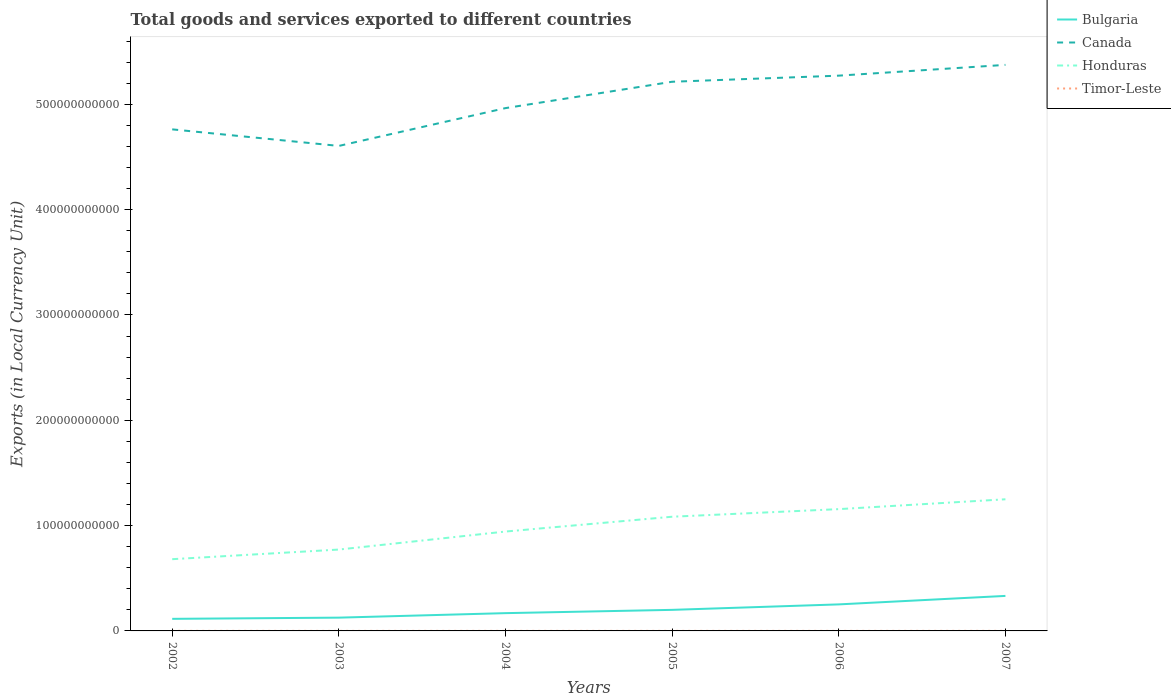Across all years, what is the maximum Amount of goods and services exports in Bulgaria?
Your response must be concise. 1.15e+1. In which year was the Amount of goods and services exports in Timor-Leste maximum?
Provide a succinct answer. 2003. What is the total Amount of goods and services exports in Timor-Leste in the graph?
Provide a short and direct response. -2.40e+07. What is the difference between the highest and the second highest Amount of goods and services exports in Canada?
Offer a very short reply. 7.69e+1. What is the difference between the highest and the lowest Amount of goods and services exports in Canada?
Make the answer very short. 3. Is the Amount of goods and services exports in Honduras strictly greater than the Amount of goods and services exports in Bulgaria over the years?
Offer a very short reply. No. How many lines are there?
Your answer should be compact. 4. How many years are there in the graph?
Your response must be concise. 6. What is the difference between two consecutive major ticks on the Y-axis?
Your answer should be very brief. 1.00e+11. Are the values on the major ticks of Y-axis written in scientific E-notation?
Your answer should be compact. No. How are the legend labels stacked?
Your answer should be very brief. Vertical. What is the title of the graph?
Offer a very short reply. Total goods and services exported to different countries. What is the label or title of the Y-axis?
Your answer should be compact. Exports (in Local Currency Unit). What is the Exports (in Local Currency Unit) in Bulgaria in 2002?
Your answer should be very brief. 1.15e+1. What is the Exports (in Local Currency Unit) in Canada in 2002?
Your answer should be compact. 4.76e+11. What is the Exports (in Local Currency Unit) in Honduras in 2002?
Keep it short and to the point. 6.81e+1. What is the Exports (in Local Currency Unit) of Timor-Leste in 2002?
Offer a terse response. 3.90e+07. What is the Exports (in Local Currency Unit) of Bulgaria in 2003?
Provide a short and direct response. 1.26e+1. What is the Exports (in Local Currency Unit) in Canada in 2003?
Your answer should be compact. 4.60e+11. What is the Exports (in Local Currency Unit) of Honduras in 2003?
Give a very brief answer. 7.73e+1. What is the Exports (in Local Currency Unit) of Timor-Leste in 2003?
Make the answer very short. 3.60e+07. What is the Exports (in Local Currency Unit) in Bulgaria in 2004?
Your response must be concise. 1.69e+1. What is the Exports (in Local Currency Unit) in Canada in 2004?
Offer a very short reply. 4.96e+11. What is the Exports (in Local Currency Unit) of Honduras in 2004?
Ensure brevity in your answer.  9.44e+1. What is the Exports (in Local Currency Unit) of Timor-Leste in 2004?
Provide a succinct answer. 3.90e+07. What is the Exports (in Local Currency Unit) of Bulgaria in 2005?
Your answer should be compact. 2.00e+1. What is the Exports (in Local Currency Unit) in Canada in 2005?
Your answer should be very brief. 5.21e+11. What is the Exports (in Local Currency Unit) in Honduras in 2005?
Offer a terse response. 1.08e+11. What is the Exports (in Local Currency Unit) of Timor-Leste in 2005?
Keep it short and to the point. 4.00e+07. What is the Exports (in Local Currency Unit) of Bulgaria in 2006?
Ensure brevity in your answer.  2.52e+1. What is the Exports (in Local Currency Unit) of Canada in 2006?
Give a very brief answer. 5.27e+11. What is the Exports (in Local Currency Unit) of Honduras in 2006?
Provide a succinct answer. 1.16e+11. What is the Exports (in Local Currency Unit) in Timor-Leste in 2006?
Your answer should be very brief. 4.50e+07. What is the Exports (in Local Currency Unit) in Bulgaria in 2007?
Offer a terse response. 3.32e+1. What is the Exports (in Local Currency Unit) in Canada in 2007?
Provide a succinct answer. 5.37e+11. What is the Exports (in Local Currency Unit) of Honduras in 2007?
Offer a very short reply. 1.25e+11. What is the Exports (in Local Currency Unit) of Timor-Leste in 2007?
Offer a terse response. 6.00e+07. Across all years, what is the maximum Exports (in Local Currency Unit) of Bulgaria?
Provide a short and direct response. 3.32e+1. Across all years, what is the maximum Exports (in Local Currency Unit) in Canada?
Provide a succinct answer. 5.37e+11. Across all years, what is the maximum Exports (in Local Currency Unit) of Honduras?
Give a very brief answer. 1.25e+11. Across all years, what is the maximum Exports (in Local Currency Unit) in Timor-Leste?
Keep it short and to the point. 6.00e+07. Across all years, what is the minimum Exports (in Local Currency Unit) of Bulgaria?
Your answer should be compact. 1.15e+1. Across all years, what is the minimum Exports (in Local Currency Unit) of Canada?
Offer a terse response. 4.60e+11. Across all years, what is the minimum Exports (in Local Currency Unit) in Honduras?
Your answer should be compact. 6.81e+1. Across all years, what is the minimum Exports (in Local Currency Unit) of Timor-Leste?
Ensure brevity in your answer.  3.60e+07. What is the total Exports (in Local Currency Unit) of Bulgaria in the graph?
Provide a short and direct response. 1.19e+11. What is the total Exports (in Local Currency Unit) of Canada in the graph?
Offer a terse response. 3.02e+12. What is the total Exports (in Local Currency Unit) in Honduras in the graph?
Make the answer very short. 5.89e+11. What is the total Exports (in Local Currency Unit) in Timor-Leste in the graph?
Provide a short and direct response. 2.59e+08. What is the difference between the Exports (in Local Currency Unit) in Bulgaria in 2002 and that in 2003?
Provide a short and direct response. -1.15e+09. What is the difference between the Exports (in Local Currency Unit) of Canada in 2002 and that in 2003?
Your answer should be compact. 1.57e+1. What is the difference between the Exports (in Local Currency Unit) of Honduras in 2002 and that in 2003?
Give a very brief answer. -9.15e+09. What is the difference between the Exports (in Local Currency Unit) of Timor-Leste in 2002 and that in 2003?
Offer a terse response. 3.00e+06. What is the difference between the Exports (in Local Currency Unit) in Bulgaria in 2002 and that in 2004?
Provide a succinct answer. -5.41e+09. What is the difference between the Exports (in Local Currency Unit) of Canada in 2002 and that in 2004?
Your answer should be very brief. -2.02e+1. What is the difference between the Exports (in Local Currency Unit) in Honduras in 2002 and that in 2004?
Offer a terse response. -2.62e+1. What is the difference between the Exports (in Local Currency Unit) in Bulgaria in 2002 and that in 2005?
Your answer should be compact. -8.53e+09. What is the difference between the Exports (in Local Currency Unit) of Canada in 2002 and that in 2005?
Provide a short and direct response. -4.52e+1. What is the difference between the Exports (in Local Currency Unit) in Honduras in 2002 and that in 2005?
Ensure brevity in your answer.  -4.03e+1. What is the difference between the Exports (in Local Currency Unit) of Bulgaria in 2002 and that in 2006?
Make the answer very short. -1.37e+1. What is the difference between the Exports (in Local Currency Unit) in Canada in 2002 and that in 2006?
Keep it short and to the point. -5.10e+1. What is the difference between the Exports (in Local Currency Unit) of Honduras in 2002 and that in 2006?
Give a very brief answer. -4.75e+1. What is the difference between the Exports (in Local Currency Unit) of Timor-Leste in 2002 and that in 2006?
Your response must be concise. -6.00e+06. What is the difference between the Exports (in Local Currency Unit) of Bulgaria in 2002 and that in 2007?
Offer a terse response. -2.18e+1. What is the difference between the Exports (in Local Currency Unit) of Canada in 2002 and that in 2007?
Ensure brevity in your answer.  -6.12e+1. What is the difference between the Exports (in Local Currency Unit) of Honduras in 2002 and that in 2007?
Offer a very short reply. -5.69e+1. What is the difference between the Exports (in Local Currency Unit) of Timor-Leste in 2002 and that in 2007?
Your answer should be very brief. -2.10e+07. What is the difference between the Exports (in Local Currency Unit) of Bulgaria in 2003 and that in 2004?
Your response must be concise. -4.27e+09. What is the difference between the Exports (in Local Currency Unit) in Canada in 2003 and that in 2004?
Give a very brief answer. -3.59e+1. What is the difference between the Exports (in Local Currency Unit) in Honduras in 2003 and that in 2004?
Offer a terse response. -1.71e+1. What is the difference between the Exports (in Local Currency Unit) in Bulgaria in 2003 and that in 2005?
Provide a short and direct response. -7.39e+09. What is the difference between the Exports (in Local Currency Unit) in Canada in 2003 and that in 2005?
Provide a succinct answer. -6.09e+1. What is the difference between the Exports (in Local Currency Unit) in Honduras in 2003 and that in 2005?
Ensure brevity in your answer.  -3.12e+1. What is the difference between the Exports (in Local Currency Unit) in Bulgaria in 2003 and that in 2006?
Make the answer very short. -1.26e+1. What is the difference between the Exports (in Local Currency Unit) in Canada in 2003 and that in 2006?
Give a very brief answer. -6.67e+1. What is the difference between the Exports (in Local Currency Unit) in Honduras in 2003 and that in 2006?
Give a very brief answer. -3.84e+1. What is the difference between the Exports (in Local Currency Unit) in Timor-Leste in 2003 and that in 2006?
Your answer should be very brief. -9.00e+06. What is the difference between the Exports (in Local Currency Unit) of Bulgaria in 2003 and that in 2007?
Provide a succinct answer. -2.06e+1. What is the difference between the Exports (in Local Currency Unit) of Canada in 2003 and that in 2007?
Keep it short and to the point. -7.69e+1. What is the difference between the Exports (in Local Currency Unit) of Honduras in 2003 and that in 2007?
Ensure brevity in your answer.  -4.77e+1. What is the difference between the Exports (in Local Currency Unit) of Timor-Leste in 2003 and that in 2007?
Keep it short and to the point. -2.40e+07. What is the difference between the Exports (in Local Currency Unit) in Bulgaria in 2004 and that in 2005?
Keep it short and to the point. -3.12e+09. What is the difference between the Exports (in Local Currency Unit) of Canada in 2004 and that in 2005?
Provide a short and direct response. -2.50e+1. What is the difference between the Exports (in Local Currency Unit) of Honduras in 2004 and that in 2005?
Your response must be concise. -1.41e+1. What is the difference between the Exports (in Local Currency Unit) in Bulgaria in 2004 and that in 2006?
Keep it short and to the point. -8.31e+09. What is the difference between the Exports (in Local Currency Unit) in Canada in 2004 and that in 2006?
Offer a very short reply. -3.08e+1. What is the difference between the Exports (in Local Currency Unit) in Honduras in 2004 and that in 2006?
Your answer should be very brief. -2.13e+1. What is the difference between the Exports (in Local Currency Unit) in Timor-Leste in 2004 and that in 2006?
Ensure brevity in your answer.  -6.00e+06. What is the difference between the Exports (in Local Currency Unit) of Bulgaria in 2004 and that in 2007?
Ensure brevity in your answer.  -1.64e+1. What is the difference between the Exports (in Local Currency Unit) of Canada in 2004 and that in 2007?
Your response must be concise. -4.10e+1. What is the difference between the Exports (in Local Currency Unit) of Honduras in 2004 and that in 2007?
Your response must be concise. -3.06e+1. What is the difference between the Exports (in Local Currency Unit) in Timor-Leste in 2004 and that in 2007?
Ensure brevity in your answer.  -2.10e+07. What is the difference between the Exports (in Local Currency Unit) in Bulgaria in 2005 and that in 2006?
Your answer should be compact. -5.19e+09. What is the difference between the Exports (in Local Currency Unit) in Canada in 2005 and that in 2006?
Give a very brief answer. -5.79e+09. What is the difference between the Exports (in Local Currency Unit) in Honduras in 2005 and that in 2006?
Offer a terse response. -7.21e+09. What is the difference between the Exports (in Local Currency Unit) in Timor-Leste in 2005 and that in 2006?
Your answer should be compact. -5.00e+06. What is the difference between the Exports (in Local Currency Unit) of Bulgaria in 2005 and that in 2007?
Your answer should be compact. -1.32e+1. What is the difference between the Exports (in Local Currency Unit) in Canada in 2005 and that in 2007?
Provide a succinct answer. -1.60e+1. What is the difference between the Exports (in Local Currency Unit) of Honduras in 2005 and that in 2007?
Your answer should be very brief. -1.66e+1. What is the difference between the Exports (in Local Currency Unit) of Timor-Leste in 2005 and that in 2007?
Provide a short and direct response. -2.00e+07. What is the difference between the Exports (in Local Currency Unit) in Bulgaria in 2006 and that in 2007?
Make the answer very short. -8.06e+09. What is the difference between the Exports (in Local Currency Unit) of Canada in 2006 and that in 2007?
Offer a very short reply. -1.02e+1. What is the difference between the Exports (in Local Currency Unit) of Honduras in 2006 and that in 2007?
Make the answer very short. -9.35e+09. What is the difference between the Exports (in Local Currency Unit) in Timor-Leste in 2006 and that in 2007?
Provide a succinct answer. -1.50e+07. What is the difference between the Exports (in Local Currency Unit) in Bulgaria in 2002 and the Exports (in Local Currency Unit) in Canada in 2003?
Offer a very short reply. -4.49e+11. What is the difference between the Exports (in Local Currency Unit) in Bulgaria in 2002 and the Exports (in Local Currency Unit) in Honduras in 2003?
Your answer should be compact. -6.58e+1. What is the difference between the Exports (in Local Currency Unit) of Bulgaria in 2002 and the Exports (in Local Currency Unit) of Timor-Leste in 2003?
Your answer should be compact. 1.14e+1. What is the difference between the Exports (in Local Currency Unit) in Canada in 2002 and the Exports (in Local Currency Unit) in Honduras in 2003?
Provide a succinct answer. 3.99e+11. What is the difference between the Exports (in Local Currency Unit) of Canada in 2002 and the Exports (in Local Currency Unit) of Timor-Leste in 2003?
Your answer should be very brief. 4.76e+11. What is the difference between the Exports (in Local Currency Unit) of Honduras in 2002 and the Exports (in Local Currency Unit) of Timor-Leste in 2003?
Make the answer very short. 6.81e+1. What is the difference between the Exports (in Local Currency Unit) of Bulgaria in 2002 and the Exports (in Local Currency Unit) of Canada in 2004?
Offer a very short reply. -4.85e+11. What is the difference between the Exports (in Local Currency Unit) in Bulgaria in 2002 and the Exports (in Local Currency Unit) in Honduras in 2004?
Your answer should be compact. -8.29e+1. What is the difference between the Exports (in Local Currency Unit) in Bulgaria in 2002 and the Exports (in Local Currency Unit) in Timor-Leste in 2004?
Your answer should be very brief. 1.14e+1. What is the difference between the Exports (in Local Currency Unit) in Canada in 2002 and the Exports (in Local Currency Unit) in Honduras in 2004?
Give a very brief answer. 3.82e+11. What is the difference between the Exports (in Local Currency Unit) in Canada in 2002 and the Exports (in Local Currency Unit) in Timor-Leste in 2004?
Your response must be concise. 4.76e+11. What is the difference between the Exports (in Local Currency Unit) of Honduras in 2002 and the Exports (in Local Currency Unit) of Timor-Leste in 2004?
Keep it short and to the point. 6.81e+1. What is the difference between the Exports (in Local Currency Unit) in Bulgaria in 2002 and the Exports (in Local Currency Unit) in Canada in 2005?
Offer a terse response. -5.10e+11. What is the difference between the Exports (in Local Currency Unit) of Bulgaria in 2002 and the Exports (in Local Currency Unit) of Honduras in 2005?
Offer a very short reply. -9.70e+1. What is the difference between the Exports (in Local Currency Unit) in Bulgaria in 2002 and the Exports (in Local Currency Unit) in Timor-Leste in 2005?
Offer a very short reply. 1.14e+1. What is the difference between the Exports (in Local Currency Unit) of Canada in 2002 and the Exports (in Local Currency Unit) of Honduras in 2005?
Your answer should be very brief. 3.68e+11. What is the difference between the Exports (in Local Currency Unit) of Canada in 2002 and the Exports (in Local Currency Unit) of Timor-Leste in 2005?
Provide a succinct answer. 4.76e+11. What is the difference between the Exports (in Local Currency Unit) in Honduras in 2002 and the Exports (in Local Currency Unit) in Timor-Leste in 2005?
Offer a terse response. 6.81e+1. What is the difference between the Exports (in Local Currency Unit) of Bulgaria in 2002 and the Exports (in Local Currency Unit) of Canada in 2006?
Offer a very short reply. -5.16e+11. What is the difference between the Exports (in Local Currency Unit) in Bulgaria in 2002 and the Exports (in Local Currency Unit) in Honduras in 2006?
Ensure brevity in your answer.  -1.04e+11. What is the difference between the Exports (in Local Currency Unit) of Bulgaria in 2002 and the Exports (in Local Currency Unit) of Timor-Leste in 2006?
Provide a succinct answer. 1.14e+1. What is the difference between the Exports (in Local Currency Unit) in Canada in 2002 and the Exports (in Local Currency Unit) in Honduras in 2006?
Offer a terse response. 3.61e+11. What is the difference between the Exports (in Local Currency Unit) of Canada in 2002 and the Exports (in Local Currency Unit) of Timor-Leste in 2006?
Provide a short and direct response. 4.76e+11. What is the difference between the Exports (in Local Currency Unit) of Honduras in 2002 and the Exports (in Local Currency Unit) of Timor-Leste in 2006?
Give a very brief answer. 6.81e+1. What is the difference between the Exports (in Local Currency Unit) of Bulgaria in 2002 and the Exports (in Local Currency Unit) of Canada in 2007?
Ensure brevity in your answer.  -5.26e+11. What is the difference between the Exports (in Local Currency Unit) of Bulgaria in 2002 and the Exports (in Local Currency Unit) of Honduras in 2007?
Your response must be concise. -1.14e+11. What is the difference between the Exports (in Local Currency Unit) of Bulgaria in 2002 and the Exports (in Local Currency Unit) of Timor-Leste in 2007?
Your answer should be compact. 1.14e+1. What is the difference between the Exports (in Local Currency Unit) in Canada in 2002 and the Exports (in Local Currency Unit) in Honduras in 2007?
Your response must be concise. 3.51e+11. What is the difference between the Exports (in Local Currency Unit) in Canada in 2002 and the Exports (in Local Currency Unit) in Timor-Leste in 2007?
Your answer should be compact. 4.76e+11. What is the difference between the Exports (in Local Currency Unit) of Honduras in 2002 and the Exports (in Local Currency Unit) of Timor-Leste in 2007?
Provide a short and direct response. 6.81e+1. What is the difference between the Exports (in Local Currency Unit) in Bulgaria in 2003 and the Exports (in Local Currency Unit) in Canada in 2004?
Your answer should be very brief. -4.84e+11. What is the difference between the Exports (in Local Currency Unit) of Bulgaria in 2003 and the Exports (in Local Currency Unit) of Honduras in 2004?
Provide a short and direct response. -8.17e+1. What is the difference between the Exports (in Local Currency Unit) in Bulgaria in 2003 and the Exports (in Local Currency Unit) in Timor-Leste in 2004?
Offer a very short reply. 1.26e+1. What is the difference between the Exports (in Local Currency Unit) in Canada in 2003 and the Exports (in Local Currency Unit) in Honduras in 2004?
Your response must be concise. 3.66e+11. What is the difference between the Exports (in Local Currency Unit) in Canada in 2003 and the Exports (in Local Currency Unit) in Timor-Leste in 2004?
Your answer should be compact. 4.60e+11. What is the difference between the Exports (in Local Currency Unit) of Honduras in 2003 and the Exports (in Local Currency Unit) of Timor-Leste in 2004?
Ensure brevity in your answer.  7.72e+1. What is the difference between the Exports (in Local Currency Unit) in Bulgaria in 2003 and the Exports (in Local Currency Unit) in Canada in 2005?
Your response must be concise. -5.09e+11. What is the difference between the Exports (in Local Currency Unit) in Bulgaria in 2003 and the Exports (in Local Currency Unit) in Honduras in 2005?
Offer a very short reply. -9.58e+1. What is the difference between the Exports (in Local Currency Unit) in Bulgaria in 2003 and the Exports (in Local Currency Unit) in Timor-Leste in 2005?
Offer a very short reply. 1.26e+1. What is the difference between the Exports (in Local Currency Unit) of Canada in 2003 and the Exports (in Local Currency Unit) of Honduras in 2005?
Offer a very short reply. 3.52e+11. What is the difference between the Exports (in Local Currency Unit) in Canada in 2003 and the Exports (in Local Currency Unit) in Timor-Leste in 2005?
Offer a terse response. 4.60e+11. What is the difference between the Exports (in Local Currency Unit) in Honduras in 2003 and the Exports (in Local Currency Unit) in Timor-Leste in 2005?
Offer a very short reply. 7.72e+1. What is the difference between the Exports (in Local Currency Unit) of Bulgaria in 2003 and the Exports (in Local Currency Unit) of Canada in 2006?
Ensure brevity in your answer.  -5.15e+11. What is the difference between the Exports (in Local Currency Unit) in Bulgaria in 2003 and the Exports (in Local Currency Unit) in Honduras in 2006?
Your response must be concise. -1.03e+11. What is the difference between the Exports (in Local Currency Unit) of Bulgaria in 2003 and the Exports (in Local Currency Unit) of Timor-Leste in 2006?
Your response must be concise. 1.26e+1. What is the difference between the Exports (in Local Currency Unit) of Canada in 2003 and the Exports (in Local Currency Unit) of Honduras in 2006?
Keep it short and to the point. 3.45e+11. What is the difference between the Exports (in Local Currency Unit) of Canada in 2003 and the Exports (in Local Currency Unit) of Timor-Leste in 2006?
Offer a very short reply. 4.60e+11. What is the difference between the Exports (in Local Currency Unit) of Honduras in 2003 and the Exports (in Local Currency Unit) of Timor-Leste in 2006?
Ensure brevity in your answer.  7.72e+1. What is the difference between the Exports (in Local Currency Unit) of Bulgaria in 2003 and the Exports (in Local Currency Unit) of Canada in 2007?
Provide a short and direct response. -5.25e+11. What is the difference between the Exports (in Local Currency Unit) of Bulgaria in 2003 and the Exports (in Local Currency Unit) of Honduras in 2007?
Provide a succinct answer. -1.12e+11. What is the difference between the Exports (in Local Currency Unit) in Bulgaria in 2003 and the Exports (in Local Currency Unit) in Timor-Leste in 2007?
Your answer should be compact. 1.25e+1. What is the difference between the Exports (in Local Currency Unit) in Canada in 2003 and the Exports (in Local Currency Unit) in Honduras in 2007?
Offer a very short reply. 3.35e+11. What is the difference between the Exports (in Local Currency Unit) of Canada in 2003 and the Exports (in Local Currency Unit) of Timor-Leste in 2007?
Your answer should be compact. 4.60e+11. What is the difference between the Exports (in Local Currency Unit) of Honduras in 2003 and the Exports (in Local Currency Unit) of Timor-Leste in 2007?
Offer a terse response. 7.72e+1. What is the difference between the Exports (in Local Currency Unit) in Bulgaria in 2004 and the Exports (in Local Currency Unit) in Canada in 2005?
Give a very brief answer. -5.05e+11. What is the difference between the Exports (in Local Currency Unit) of Bulgaria in 2004 and the Exports (in Local Currency Unit) of Honduras in 2005?
Ensure brevity in your answer.  -9.15e+1. What is the difference between the Exports (in Local Currency Unit) of Bulgaria in 2004 and the Exports (in Local Currency Unit) of Timor-Leste in 2005?
Offer a terse response. 1.68e+1. What is the difference between the Exports (in Local Currency Unit) in Canada in 2004 and the Exports (in Local Currency Unit) in Honduras in 2005?
Your answer should be very brief. 3.88e+11. What is the difference between the Exports (in Local Currency Unit) in Canada in 2004 and the Exports (in Local Currency Unit) in Timor-Leste in 2005?
Give a very brief answer. 4.96e+11. What is the difference between the Exports (in Local Currency Unit) of Honduras in 2004 and the Exports (in Local Currency Unit) of Timor-Leste in 2005?
Your response must be concise. 9.43e+1. What is the difference between the Exports (in Local Currency Unit) of Bulgaria in 2004 and the Exports (in Local Currency Unit) of Canada in 2006?
Ensure brevity in your answer.  -5.10e+11. What is the difference between the Exports (in Local Currency Unit) in Bulgaria in 2004 and the Exports (in Local Currency Unit) in Honduras in 2006?
Offer a terse response. -9.88e+1. What is the difference between the Exports (in Local Currency Unit) of Bulgaria in 2004 and the Exports (in Local Currency Unit) of Timor-Leste in 2006?
Provide a short and direct response. 1.68e+1. What is the difference between the Exports (in Local Currency Unit) in Canada in 2004 and the Exports (in Local Currency Unit) in Honduras in 2006?
Offer a very short reply. 3.81e+11. What is the difference between the Exports (in Local Currency Unit) in Canada in 2004 and the Exports (in Local Currency Unit) in Timor-Leste in 2006?
Your answer should be compact. 4.96e+11. What is the difference between the Exports (in Local Currency Unit) of Honduras in 2004 and the Exports (in Local Currency Unit) of Timor-Leste in 2006?
Offer a terse response. 9.43e+1. What is the difference between the Exports (in Local Currency Unit) in Bulgaria in 2004 and the Exports (in Local Currency Unit) in Canada in 2007?
Your response must be concise. -5.21e+11. What is the difference between the Exports (in Local Currency Unit) of Bulgaria in 2004 and the Exports (in Local Currency Unit) of Honduras in 2007?
Offer a very short reply. -1.08e+11. What is the difference between the Exports (in Local Currency Unit) in Bulgaria in 2004 and the Exports (in Local Currency Unit) in Timor-Leste in 2007?
Your response must be concise. 1.68e+1. What is the difference between the Exports (in Local Currency Unit) of Canada in 2004 and the Exports (in Local Currency Unit) of Honduras in 2007?
Provide a succinct answer. 3.71e+11. What is the difference between the Exports (in Local Currency Unit) of Canada in 2004 and the Exports (in Local Currency Unit) of Timor-Leste in 2007?
Keep it short and to the point. 4.96e+11. What is the difference between the Exports (in Local Currency Unit) in Honduras in 2004 and the Exports (in Local Currency Unit) in Timor-Leste in 2007?
Keep it short and to the point. 9.43e+1. What is the difference between the Exports (in Local Currency Unit) of Bulgaria in 2005 and the Exports (in Local Currency Unit) of Canada in 2006?
Give a very brief answer. -5.07e+11. What is the difference between the Exports (in Local Currency Unit) of Bulgaria in 2005 and the Exports (in Local Currency Unit) of Honduras in 2006?
Give a very brief answer. -9.56e+1. What is the difference between the Exports (in Local Currency Unit) in Bulgaria in 2005 and the Exports (in Local Currency Unit) in Timor-Leste in 2006?
Your answer should be very brief. 2.00e+1. What is the difference between the Exports (in Local Currency Unit) of Canada in 2005 and the Exports (in Local Currency Unit) of Honduras in 2006?
Offer a terse response. 4.06e+11. What is the difference between the Exports (in Local Currency Unit) of Canada in 2005 and the Exports (in Local Currency Unit) of Timor-Leste in 2006?
Ensure brevity in your answer.  5.21e+11. What is the difference between the Exports (in Local Currency Unit) in Honduras in 2005 and the Exports (in Local Currency Unit) in Timor-Leste in 2006?
Ensure brevity in your answer.  1.08e+11. What is the difference between the Exports (in Local Currency Unit) in Bulgaria in 2005 and the Exports (in Local Currency Unit) in Canada in 2007?
Ensure brevity in your answer.  -5.17e+11. What is the difference between the Exports (in Local Currency Unit) in Bulgaria in 2005 and the Exports (in Local Currency Unit) in Honduras in 2007?
Offer a terse response. -1.05e+11. What is the difference between the Exports (in Local Currency Unit) of Bulgaria in 2005 and the Exports (in Local Currency Unit) of Timor-Leste in 2007?
Keep it short and to the point. 1.99e+1. What is the difference between the Exports (in Local Currency Unit) in Canada in 2005 and the Exports (in Local Currency Unit) in Honduras in 2007?
Give a very brief answer. 3.96e+11. What is the difference between the Exports (in Local Currency Unit) of Canada in 2005 and the Exports (in Local Currency Unit) of Timor-Leste in 2007?
Offer a very short reply. 5.21e+11. What is the difference between the Exports (in Local Currency Unit) of Honduras in 2005 and the Exports (in Local Currency Unit) of Timor-Leste in 2007?
Your answer should be compact. 1.08e+11. What is the difference between the Exports (in Local Currency Unit) of Bulgaria in 2006 and the Exports (in Local Currency Unit) of Canada in 2007?
Make the answer very short. -5.12e+11. What is the difference between the Exports (in Local Currency Unit) of Bulgaria in 2006 and the Exports (in Local Currency Unit) of Honduras in 2007?
Give a very brief answer. -9.98e+1. What is the difference between the Exports (in Local Currency Unit) of Bulgaria in 2006 and the Exports (in Local Currency Unit) of Timor-Leste in 2007?
Your answer should be compact. 2.51e+1. What is the difference between the Exports (in Local Currency Unit) of Canada in 2006 and the Exports (in Local Currency Unit) of Honduras in 2007?
Offer a very short reply. 4.02e+11. What is the difference between the Exports (in Local Currency Unit) of Canada in 2006 and the Exports (in Local Currency Unit) of Timor-Leste in 2007?
Your response must be concise. 5.27e+11. What is the difference between the Exports (in Local Currency Unit) in Honduras in 2006 and the Exports (in Local Currency Unit) in Timor-Leste in 2007?
Ensure brevity in your answer.  1.16e+11. What is the average Exports (in Local Currency Unit) in Bulgaria per year?
Offer a very short reply. 1.99e+1. What is the average Exports (in Local Currency Unit) of Canada per year?
Provide a short and direct response. 5.03e+11. What is the average Exports (in Local Currency Unit) in Honduras per year?
Give a very brief answer. 9.81e+1. What is the average Exports (in Local Currency Unit) in Timor-Leste per year?
Your response must be concise. 4.32e+07. In the year 2002, what is the difference between the Exports (in Local Currency Unit) in Bulgaria and Exports (in Local Currency Unit) in Canada?
Your response must be concise. -4.65e+11. In the year 2002, what is the difference between the Exports (in Local Currency Unit) in Bulgaria and Exports (in Local Currency Unit) in Honduras?
Ensure brevity in your answer.  -5.66e+1. In the year 2002, what is the difference between the Exports (in Local Currency Unit) of Bulgaria and Exports (in Local Currency Unit) of Timor-Leste?
Your answer should be compact. 1.14e+1. In the year 2002, what is the difference between the Exports (in Local Currency Unit) in Canada and Exports (in Local Currency Unit) in Honduras?
Offer a very short reply. 4.08e+11. In the year 2002, what is the difference between the Exports (in Local Currency Unit) of Canada and Exports (in Local Currency Unit) of Timor-Leste?
Ensure brevity in your answer.  4.76e+11. In the year 2002, what is the difference between the Exports (in Local Currency Unit) in Honduras and Exports (in Local Currency Unit) in Timor-Leste?
Make the answer very short. 6.81e+1. In the year 2003, what is the difference between the Exports (in Local Currency Unit) of Bulgaria and Exports (in Local Currency Unit) of Canada?
Provide a succinct answer. -4.48e+11. In the year 2003, what is the difference between the Exports (in Local Currency Unit) of Bulgaria and Exports (in Local Currency Unit) of Honduras?
Provide a short and direct response. -6.46e+1. In the year 2003, what is the difference between the Exports (in Local Currency Unit) of Bulgaria and Exports (in Local Currency Unit) of Timor-Leste?
Keep it short and to the point. 1.26e+1. In the year 2003, what is the difference between the Exports (in Local Currency Unit) of Canada and Exports (in Local Currency Unit) of Honduras?
Ensure brevity in your answer.  3.83e+11. In the year 2003, what is the difference between the Exports (in Local Currency Unit) of Canada and Exports (in Local Currency Unit) of Timor-Leste?
Your answer should be compact. 4.60e+11. In the year 2003, what is the difference between the Exports (in Local Currency Unit) in Honduras and Exports (in Local Currency Unit) in Timor-Leste?
Provide a succinct answer. 7.72e+1. In the year 2004, what is the difference between the Exports (in Local Currency Unit) of Bulgaria and Exports (in Local Currency Unit) of Canada?
Provide a succinct answer. -4.79e+11. In the year 2004, what is the difference between the Exports (in Local Currency Unit) in Bulgaria and Exports (in Local Currency Unit) in Honduras?
Provide a short and direct response. -7.75e+1. In the year 2004, what is the difference between the Exports (in Local Currency Unit) of Bulgaria and Exports (in Local Currency Unit) of Timor-Leste?
Offer a terse response. 1.68e+1. In the year 2004, what is the difference between the Exports (in Local Currency Unit) in Canada and Exports (in Local Currency Unit) in Honduras?
Your answer should be very brief. 4.02e+11. In the year 2004, what is the difference between the Exports (in Local Currency Unit) in Canada and Exports (in Local Currency Unit) in Timor-Leste?
Provide a short and direct response. 4.96e+11. In the year 2004, what is the difference between the Exports (in Local Currency Unit) in Honduras and Exports (in Local Currency Unit) in Timor-Leste?
Provide a short and direct response. 9.43e+1. In the year 2005, what is the difference between the Exports (in Local Currency Unit) in Bulgaria and Exports (in Local Currency Unit) in Canada?
Give a very brief answer. -5.01e+11. In the year 2005, what is the difference between the Exports (in Local Currency Unit) of Bulgaria and Exports (in Local Currency Unit) of Honduras?
Offer a terse response. -8.84e+1. In the year 2005, what is the difference between the Exports (in Local Currency Unit) in Bulgaria and Exports (in Local Currency Unit) in Timor-Leste?
Provide a short and direct response. 2.00e+1. In the year 2005, what is the difference between the Exports (in Local Currency Unit) of Canada and Exports (in Local Currency Unit) of Honduras?
Keep it short and to the point. 4.13e+11. In the year 2005, what is the difference between the Exports (in Local Currency Unit) in Canada and Exports (in Local Currency Unit) in Timor-Leste?
Offer a very short reply. 5.21e+11. In the year 2005, what is the difference between the Exports (in Local Currency Unit) in Honduras and Exports (in Local Currency Unit) in Timor-Leste?
Provide a short and direct response. 1.08e+11. In the year 2006, what is the difference between the Exports (in Local Currency Unit) of Bulgaria and Exports (in Local Currency Unit) of Canada?
Ensure brevity in your answer.  -5.02e+11. In the year 2006, what is the difference between the Exports (in Local Currency Unit) in Bulgaria and Exports (in Local Currency Unit) in Honduras?
Ensure brevity in your answer.  -9.04e+1. In the year 2006, what is the difference between the Exports (in Local Currency Unit) in Bulgaria and Exports (in Local Currency Unit) in Timor-Leste?
Your response must be concise. 2.51e+1. In the year 2006, what is the difference between the Exports (in Local Currency Unit) of Canada and Exports (in Local Currency Unit) of Honduras?
Your response must be concise. 4.12e+11. In the year 2006, what is the difference between the Exports (in Local Currency Unit) in Canada and Exports (in Local Currency Unit) in Timor-Leste?
Provide a succinct answer. 5.27e+11. In the year 2006, what is the difference between the Exports (in Local Currency Unit) in Honduras and Exports (in Local Currency Unit) in Timor-Leste?
Ensure brevity in your answer.  1.16e+11. In the year 2007, what is the difference between the Exports (in Local Currency Unit) of Bulgaria and Exports (in Local Currency Unit) of Canada?
Provide a short and direct response. -5.04e+11. In the year 2007, what is the difference between the Exports (in Local Currency Unit) in Bulgaria and Exports (in Local Currency Unit) in Honduras?
Keep it short and to the point. -9.17e+1. In the year 2007, what is the difference between the Exports (in Local Currency Unit) of Bulgaria and Exports (in Local Currency Unit) of Timor-Leste?
Make the answer very short. 3.32e+1. In the year 2007, what is the difference between the Exports (in Local Currency Unit) of Canada and Exports (in Local Currency Unit) of Honduras?
Ensure brevity in your answer.  4.12e+11. In the year 2007, what is the difference between the Exports (in Local Currency Unit) in Canada and Exports (in Local Currency Unit) in Timor-Leste?
Keep it short and to the point. 5.37e+11. In the year 2007, what is the difference between the Exports (in Local Currency Unit) in Honduras and Exports (in Local Currency Unit) in Timor-Leste?
Offer a terse response. 1.25e+11. What is the ratio of the Exports (in Local Currency Unit) of Bulgaria in 2002 to that in 2003?
Provide a succinct answer. 0.91. What is the ratio of the Exports (in Local Currency Unit) of Canada in 2002 to that in 2003?
Provide a succinct answer. 1.03. What is the ratio of the Exports (in Local Currency Unit) of Honduras in 2002 to that in 2003?
Your response must be concise. 0.88. What is the ratio of the Exports (in Local Currency Unit) of Bulgaria in 2002 to that in 2004?
Your answer should be very brief. 0.68. What is the ratio of the Exports (in Local Currency Unit) in Canada in 2002 to that in 2004?
Your answer should be compact. 0.96. What is the ratio of the Exports (in Local Currency Unit) in Honduras in 2002 to that in 2004?
Your answer should be very brief. 0.72. What is the ratio of the Exports (in Local Currency Unit) of Bulgaria in 2002 to that in 2005?
Provide a succinct answer. 0.57. What is the ratio of the Exports (in Local Currency Unit) of Canada in 2002 to that in 2005?
Ensure brevity in your answer.  0.91. What is the ratio of the Exports (in Local Currency Unit) in Honduras in 2002 to that in 2005?
Ensure brevity in your answer.  0.63. What is the ratio of the Exports (in Local Currency Unit) in Timor-Leste in 2002 to that in 2005?
Keep it short and to the point. 0.97. What is the ratio of the Exports (in Local Currency Unit) in Bulgaria in 2002 to that in 2006?
Make the answer very short. 0.46. What is the ratio of the Exports (in Local Currency Unit) of Canada in 2002 to that in 2006?
Provide a succinct answer. 0.9. What is the ratio of the Exports (in Local Currency Unit) in Honduras in 2002 to that in 2006?
Give a very brief answer. 0.59. What is the ratio of the Exports (in Local Currency Unit) in Timor-Leste in 2002 to that in 2006?
Provide a succinct answer. 0.87. What is the ratio of the Exports (in Local Currency Unit) in Bulgaria in 2002 to that in 2007?
Give a very brief answer. 0.34. What is the ratio of the Exports (in Local Currency Unit) in Canada in 2002 to that in 2007?
Keep it short and to the point. 0.89. What is the ratio of the Exports (in Local Currency Unit) of Honduras in 2002 to that in 2007?
Ensure brevity in your answer.  0.55. What is the ratio of the Exports (in Local Currency Unit) in Timor-Leste in 2002 to that in 2007?
Make the answer very short. 0.65. What is the ratio of the Exports (in Local Currency Unit) in Bulgaria in 2003 to that in 2004?
Make the answer very short. 0.75. What is the ratio of the Exports (in Local Currency Unit) in Canada in 2003 to that in 2004?
Your response must be concise. 0.93. What is the ratio of the Exports (in Local Currency Unit) of Honduras in 2003 to that in 2004?
Your answer should be very brief. 0.82. What is the ratio of the Exports (in Local Currency Unit) in Bulgaria in 2003 to that in 2005?
Your answer should be very brief. 0.63. What is the ratio of the Exports (in Local Currency Unit) in Canada in 2003 to that in 2005?
Your response must be concise. 0.88. What is the ratio of the Exports (in Local Currency Unit) in Honduras in 2003 to that in 2005?
Offer a very short reply. 0.71. What is the ratio of the Exports (in Local Currency Unit) of Timor-Leste in 2003 to that in 2005?
Give a very brief answer. 0.9. What is the ratio of the Exports (in Local Currency Unit) of Bulgaria in 2003 to that in 2006?
Offer a terse response. 0.5. What is the ratio of the Exports (in Local Currency Unit) in Canada in 2003 to that in 2006?
Ensure brevity in your answer.  0.87. What is the ratio of the Exports (in Local Currency Unit) of Honduras in 2003 to that in 2006?
Keep it short and to the point. 0.67. What is the ratio of the Exports (in Local Currency Unit) of Bulgaria in 2003 to that in 2007?
Ensure brevity in your answer.  0.38. What is the ratio of the Exports (in Local Currency Unit) of Canada in 2003 to that in 2007?
Make the answer very short. 0.86. What is the ratio of the Exports (in Local Currency Unit) in Honduras in 2003 to that in 2007?
Ensure brevity in your answer.  0.62. What is the ratio of the Exports (in Local Currency Unit) of Bulgaria in 2004 to that in 2005?
Give a very brief answer. 0.84. What is the ratio of the Exports (in Local Currency Unit) of Canada in 2004 to that in 2005?
Offer a very short reply. 0.95. What is the ratio of the Exports (in Local Currency Unit) in Honduras in 2004 to that in 2005?
Your answer should be very brief. 0.87. What is the ratio of the Exports (in Local Currency Unit) in Bulgaria in 2004 to that in 2006?
Your answer should be very brief. 0.67. What is the ratio of the Exports (in Local Currency Unit) in Canada in 2004 to that in 2006?
Offer a terse response. 0.94. What is the ratio of the Exports (in Local Currency Unit) in Honduras in 2004 to that in 2006?
Your answer should be compact. 0.82. What is the ratio of the Exports (in Local Currency Unit) in Timor-Leste in 2004 to that in 2006?
Your answer should be very brief. 0.87. What is the ratio of the Exports (in Local Currency Unit) in Bulgaria in 2004 to that in 2007?
Provide a succinct answer. 0.51. What is the ratio of the Exports (in Local Currency Unit) in Canada in 2004 to that in 2007?
Provide a short and direct response. 0.92. What is the ratio of the Exports (in Local Currency Unit) of Honduras in 2004 to that in 2007?
Your answer should be compact. 0.76. What is the ratio of the Exports (in Local Currency Unit) in Timor-Leste in 2004 to that in 2007?
Offer a terse response. 0.65. What is the ratio of the Exports (in Local Currency Unit) of Bulgaria in 2005 to that in 2006?
Your answer should be very brief. 0.79. What is the ratio of the Exports (in Local Currency Unit) of Canada in 2005 to that in 2006?
Keep it short and to the point. 0.99. What is the ratio of the Exports (in Local Currency Unit) in Honduras in 2005 to that in 2006?
Provide a succinct answer. 0.94. What is the ratio of the Exports (in Local Currency Unit) in Timor-Leste in 2005 to that in 2006?
Make the answer very short. 0.89. What is the ratio of the Exports (in Local Currency Unit) of Bulgaria in 2005 to that in 2007?
Provide a short and direct response. 0.6. What is the ratio of the Exports (in Local Currency Unit) of Canada in 2005 to that in 2007?
Offer a very short reply. 0.97. What is the ratio of the Exports (in Local Currency Unit) in Honduras in 2005 to that in 2007?
Ensure brevity in your answer.  0.87. What is the ratio of the Exports (in Local Currency Unit) of Bulgaria in 2006 to that in 2007?
Give a very brief answer. 0.76. What is the ratio of the Exports (in Local Currency Unit) in Honduras in 2006 to that in 2007?
Offer a very short reply. 0.93. What is the ratio of the Exports (in Local Currency Unit) of Timor-Leste in 2006 to that in 2007?
Provide a short and direct response. 0.75. What is the difference between the highest and the second highest Exports (in Local Currency Unit) in Bulgaria?
Keep it short and to the point. 8.06e+09. What is the difference between the highest and the second highest Exports (in Local Currency Unit) in Canada?
Provide a short and direct response. 1.02e+1. What is the difference between the highest and the second highest Exports (in Local Currency Unit) of Honduras?
Ensure brevity in your answer.  9.35e+09. What is the difference between the highest and the second highest Exports (in Local Currency Unit) of Timor-Leste?
Your response must be concise. 1.50e+07. What is the difference between the highest and the lowest Exports (in Local Currency Unit) of Bulgaria?
Make the answer very short. 2.18e+1. What is the difference between the highest and the lowest Exports (in Local Currency Unit) of Canada?
Offer a very short reply. 7.69e+1. What is the difference between the highest and the lowest Exports (in Local Currency Unit) in Honduras?
Provide a short and direct response. 5.69e+1. What is the difference between the highest and the lowest Exports (in Local Currency Unit) in Timor-Leste?
Ensure brevity in your answer.  2.40e+07. 